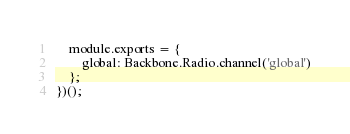<code> <loc_0><loc_0><loc_500><loc_500><_JavaScript_>    module.exports = {
        global: Backbone.Radio.channel('global')
    };
})();
</code> 